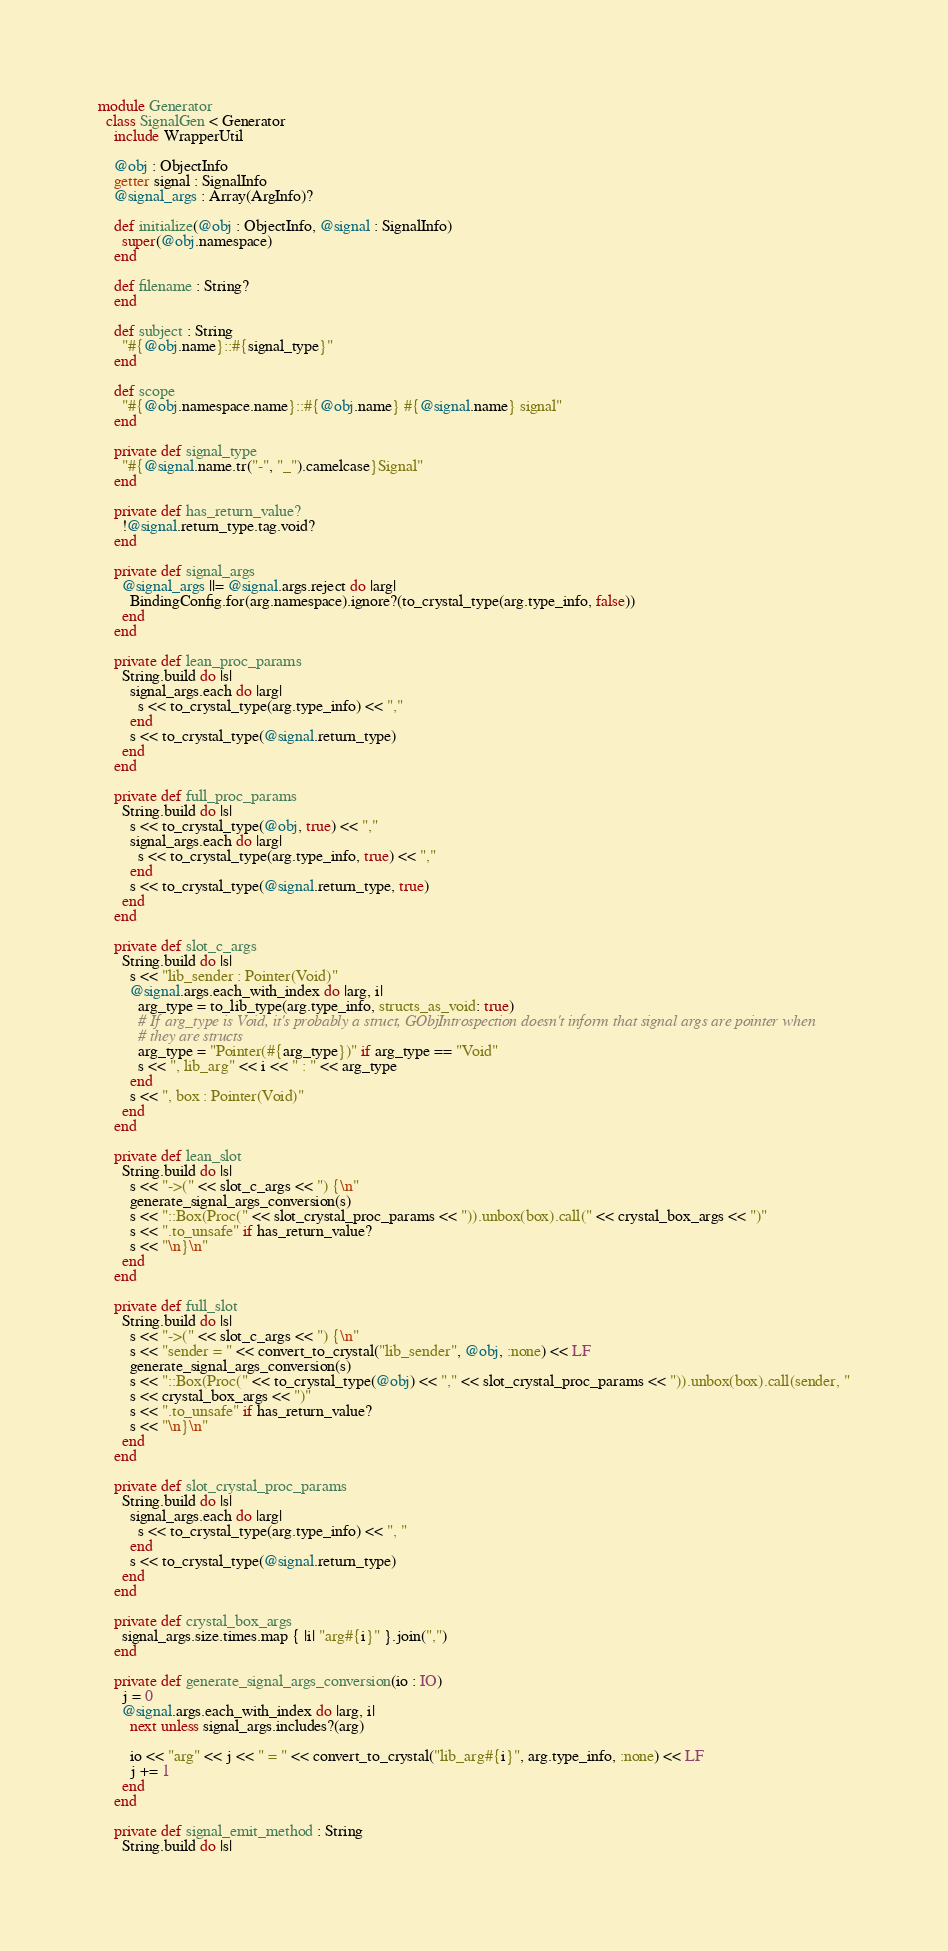<code> <loc_0><loc_0><loc_500><loc_500><_Crystal_>module Generator
  class SignalGen < Generator
    include WrapperUtil

    @obj : ObjectInfo
    getter signal : SignalInfo
    @signal_args : Array(ArgInfo)?

    def initialize(@obj : ObjectInfo, @signal : SignalInfo)
      super(@obj.namespace)
    end

    def filename : String?
    end

    def subject : String
      "#{@obj.name}::#{signal_type}"
    end

    def scope
      "#{@obj.namespace.name}::#{@obj.name} #{@signal.name} signal"
    end

    private def signal_type
      "#{@signal.name.tr("-", "_").camelcase}Signal"
    end

    private def has_return_value?
      !@signal.return_type.tag.void?
    end

    private def signal_args
      @signal_args ||= @signal.args.reject do |arg|
        BindingConfig.for(arg.namespace).ignore?(to_crystal_type(arg.type_info, false))
      end
    end

    private def lean_proc_params
      String.build do |s|
        signal_args.each do |arg|
          s << to_crystal_type(arg.type_info) << ","
        end
        s << to_crystal_type(@signal.return_type)
      end
    end

    private def full_proc_params
      String.build do |s|
        s << to_crystal_type(@obj, true) << ","
        signal_args.each do |arg|
          s << to_crystal_type(arg.type_info, true) << ","
        end
        s << to_crystal_type(@signal.return_type, true)
      end
    end

    private def slot_c_args
      String.build do |s|
        s << "lib_sender : Pointer(Void)"
        @signal.args.each_with_index do |arg, i|
          arg_type = to_lib_type(arg.type_info, structs_as_void: true)
          # If arg_type is Void, it's probably a struct, GObjIntrospection doesn't inform that signal args are pointer when
          # they are structs
          arg_type = "Pointer(#{arg_type})" if arg_type == "Void"
          s << ", lib_arg" << i << " : " << arg_type
        end
        s << ", box : Pointer(Void)"
      end
    end

    private def lean_slot
      String.build do |s|
        s << "->(" << slot_c_args << ") {\n"
        generate_signal_args_conversion(s)
        s << "::Box(Proc(" << slot_crystal_proc_params << ")).unbox(box).call(" << crystal_box_args << ")"
        s << ".to_unsafe" if has_return_value?
        s << "\n}\n"
      end
    end

    private def full_slot
      String.build do |s|
        s << "->(" << slot_c_args << ") {\n"
        s << "sender = " << convert_to_crystal("lib_sender", @obj, :none) << LF
        generate_signal_args_conversion(s)
        s << "::Box(Proc(" << to_crystal_type(@obj) << "," << slot_crystal_proc_params << ")).unbox(box).call(sender, "
        s << crystal_box_args << ")"
        s << ".to_unsafe" if has_return_value?
        s << "\n}\n"
      end
    end

    private def slot_crystal_proc_params
      String.build do |s|
        signal_args.each do |arg|
          s << to_crystal_type(arg.type_info) << ", "
        end
        s << to_crystal_type(@signal.return_type)
      end
    end

    private def crystal_box_args
      signal_args.size.times.map { |i| "arg#{i}" }.join(",")
    end

    private def generate_signal_args_conversion(io : IO)
      j = 0
      @signal.args.each_with_index do |arg, i|
        next unless signal_args.includes?(arg)

        io << "arg" << j << " = " << convert_to_crystal("lib_arg#{i}", arg.type_info, :none) << LF
        j += 1
      end
    end

    private def signal_emit_method : String
      String.build do |s|</code> 